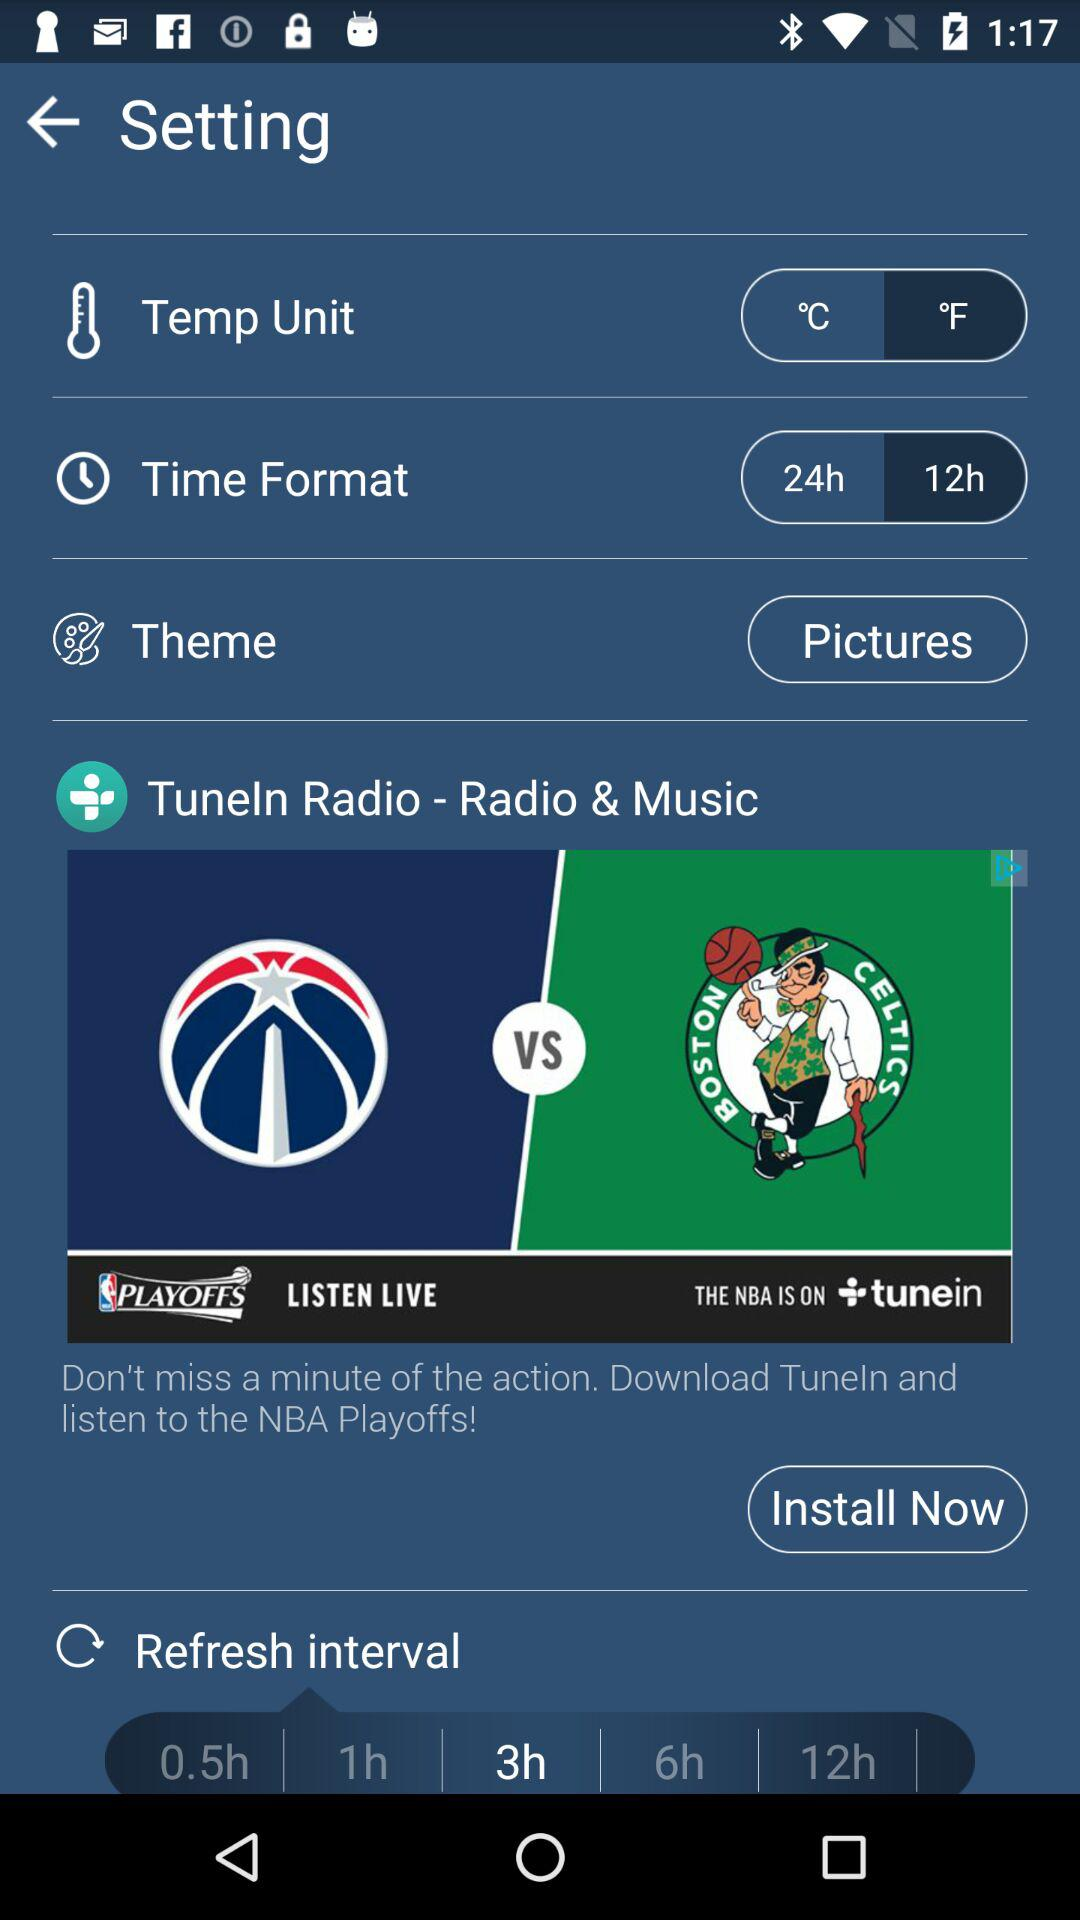What is the selected theme? The selected theme is "Pictures". 